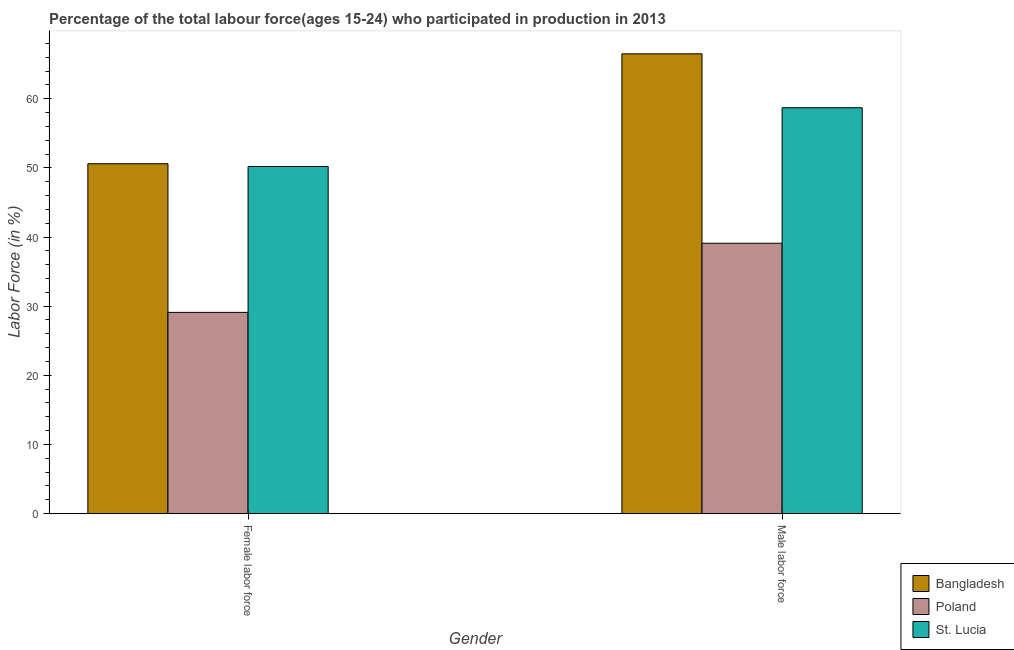How many different coloured bars are there?
Provide a succinct answer. 3. How many groups of bars are there?
Provide a succinct answer. 2. Are the number of bars per tick equal to the number of legend labels?
Your answer should be very brief. Yes. Are the number of bars on each tick of the X-axis equal?
Your answer should be very brief. Yes. How many bars are there on the 1st tick from the left?
Provide a short and direct response. 3. How many bars are there on the 2nd tick from the right?
Keep it short and to the point. 3. What is the label of the 1st group of bars from the left?
Make the answer very short. Female labor force. What is the percentage of female labor force in Poland?
Ensure brevity in your answer.  29.1. Across all countries, what is the maximum percentage of female labor force?
Offer a very short reply. 50.6. Across all countries, what is the minimum percentage of male labour force?
Give a very brief answer. 39.1. In which country was the percentage of female labor force maximum?
Offer a terse response. Bangladesh. In which country was the percentage of male labour force minimum?
Your response must be concise. Poland. What is the total percentage of female labor force in the graph?
Offer a very short reply. 129.9. What is the difference between the percentage of male labour force in Poland and that in Bangladesh?
Provide a succinct answer. -27.4. What is the difference between the percentage of female labor force in St. Lucia and the percentage of male labour force in Poland?
Provide a succinct answer. 11.1. What is the average percentage of male labour force per country?
Provide a succinct answer. 54.77. What is the difference between the percentage of female labor force and percentage of male labour force in St. Lucia?
Provide a short and direct response. -8.5. What is the ratio of the percentage of female labor force in Poland to that in St. Lucia?
Provide a succinct answer. 0.58. Is the percentage of female labor force in Poland less than that in St. Lucia?
Provide a succinct answer. Yes. In how many countries, is the percentage of male labour force greater than the average percentage of male labour force taken over all countries?
Your response must be concise. 2. What does the 1st bar from the right in Male labor force represents?
Provide a short and direct response. St. Lucia. How many countries are there in the graph?
Make the answer very short. 3. What is the difference between two consecutive major ticks on the Y-axis?
Make the answer very short. 10. Does the graph contain grids?
Provide a succinct answer. No. How many legend labels are there?
Give a very brief answer. 3. How are the legend labels stacked?
Your response must be concise. Vertical. What is the title of the graph?
Give a very brief answer. Percentage of the total labour force(ages 15-24) who participated in production in 2013. What is the Labor Force (in %) in Bangladesh in Female labor force?
Ensure brevity in your answer.  50.6. What is the Labor Force (in %) of Poland in Female labor force?
Your answer should be compact. 29.1. What is the Labor Force (in %) of St. Lucia in Female labor force?
Keep it short and to the point. 50.2. What is the Labor Force (in %) in Bangladesh in Male labor force?
Your answer should be very brief. 66.5. What is the Labor Force (in %) in Poland in Male labor force?
Offer a very short reply. 39.1. What is the Labor Force (in %) of St. Lucia in Male labor force?
Your answer should be very brief. 58.7. Across all Gender, what is the maximum Labor Force (in %) of Bangladesh?
Your response must be concise. 66.5. Across all Gender, what is the maximum Labor Force (in %) in Poland?
Your response must be concise. 39.1. Across all Gender, what is the maximum Labor Force (in %) in St. Lucia?
Give a very brief answer. 58.7. Across all Gender, what is the minimum Labor Force (in %) of Bangladesh?
Your response must be concise. 50.6. Across all Gender, what is the minimum Labor Force (in %) of Poland?
Make the answer very short. 29.1. Across all Gender, what is the minimum Labor Force (in %) of St. Lucia?
Offer a very short reply. 50.2. What is the total Labor Force (in %) in Bangladesh in the graph?
Your response must be concise. 117.1. What is the total Labor Force (in %) of Poland in the graph?
Your answer should be compact. 68.2. What is the total Labor Force (in %) in St. Lucia in the graph?
Provide a succinct answer. 108.9. What is the difference between the Labor Force (in %) of Bangladesh in Female labor force and that in Male labor force?
Your answer should be compact. -15.9. What is the difference between the Labor Force (in %) in Poland in Female labor force and that in Male labor force?
Your answer should be very brief. -10. What is the difference between the Labor Force (in %) of St. Lucia in Female labor force and that in Male labor force?
Give a very brief answer. -8.5. What is the difference between the Labor Force (in %) in Bangladesh in Female labor force and the Labor Force (in %) in Poland in Male labor force?
Keep it short and to the point. 11.5. What is the difference between the Labor Force (in %) of Poland in Female labor force and the Labor Force (in %) of St. Lucia in Male labor force?
Provide a succinct answer. -29.6. What is the average Labor Force (in %) in Bangladesh per Gender?
Your answer should be compact. 58.55. What is the average Labor Force (in %) of Poland per Gender?
Your answer should be very brief. 34.1. What is the average Labor Force (in %) in St. Lucia per Gender?
Your response must be concise. 54.45. What is the difference between the Labor Force (in %) in Poland and Labor Force (in %) in St. Lucia in Female labor force?
Keep it short and to the point. -21.1. What is the difference between the Labor Force (in %) in Bangladesh and Labor Force (in %) in Poland in Male labor force?
Your answer should be very brief. 27.4. What is the difference between the Labor Force (in %) in Bangladesh and Labor Force (in %) in St. Lucia in Male labor force?
Provide a succinct answer. 7.8. What is the difference between the Labor Force (in %) of Poland and Labor Force (in %) of St. Lucia in Male labor force?
Your answer should be very brief. -19.6. What is the ratio of the Labor Force (in %) of Bangladesh in Female labor force to that in Male labor force?
Your answer should be compact. 0.76. What is the ratio of the Labor Force (in %) in Poland in Female labor force to that in Male labor force?
Give a very brief answer. 0.74. What is the ratio of the Labor Force (in %) in St. Lucia in Female labor force to that in Male labor force?
Ensure brevity in your answer.  0.86. What is the difference between the highest and the second highest Labor Force (in %) of Bangladesh?
Your response must be concise. 15.9. What is the difference between the highest and the lowest Labor Force (in %) in St. Lucia?
Offer a very short reply. 8.5. 